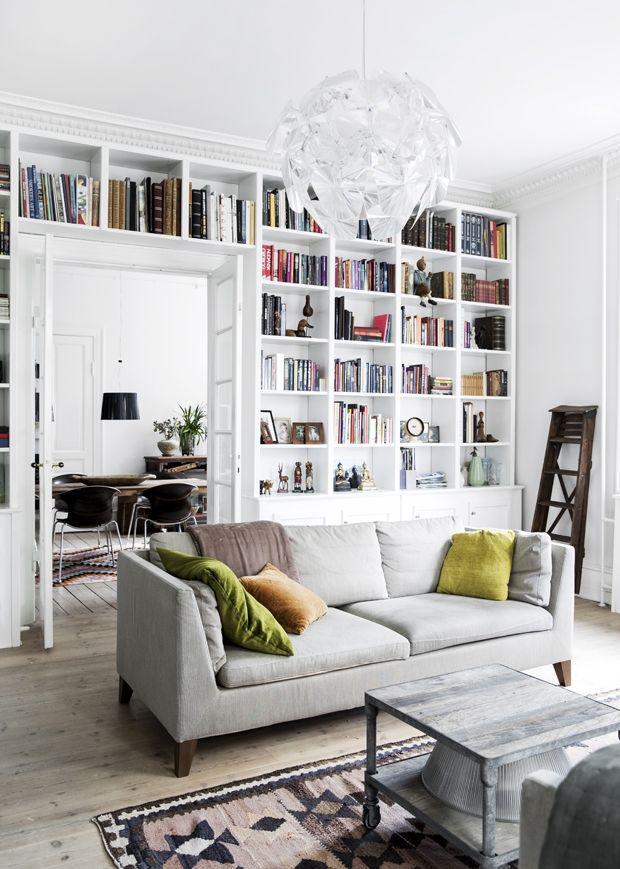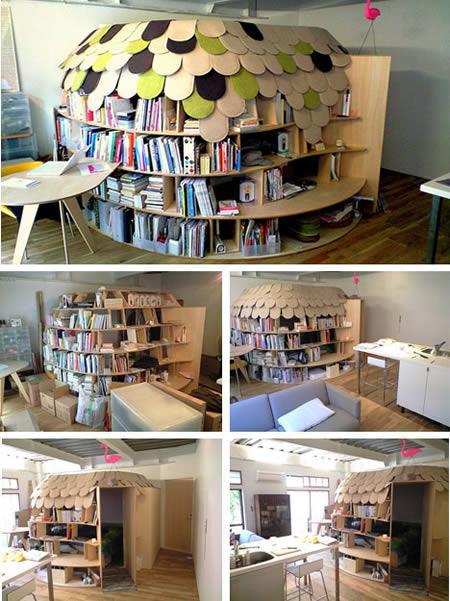The first image is the image on the left, the second image is the image on the right. Assess this claim about the two images: "In one image, a seating area is in front of an interior doorway that is surrounded by bookcases.". Correct or not? Answer yes or no. Yes. 